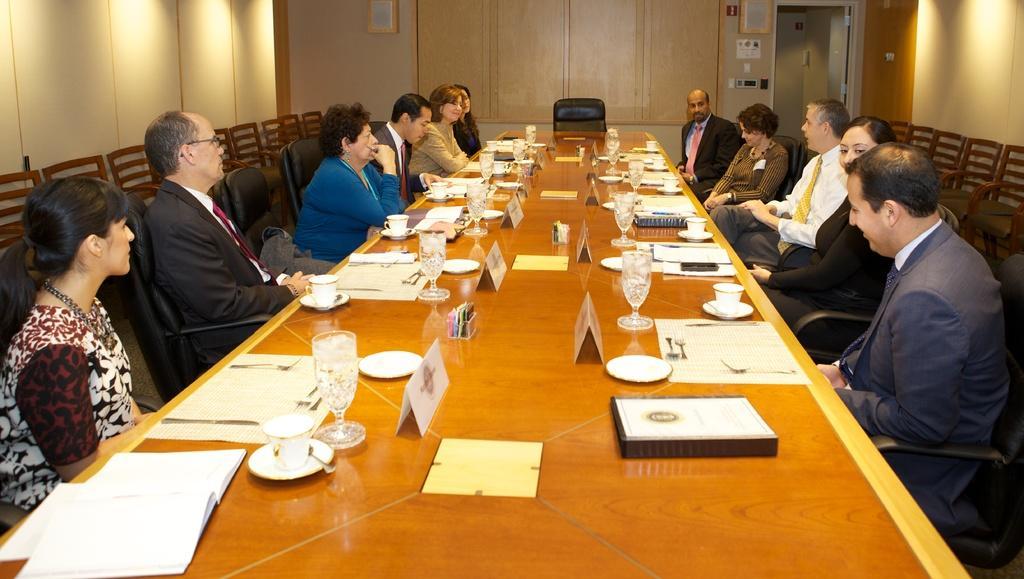Can you describe this image briefly? In the image we can see there are people who are sitting on chair and on table there is a wine glass, menu card and plate. 